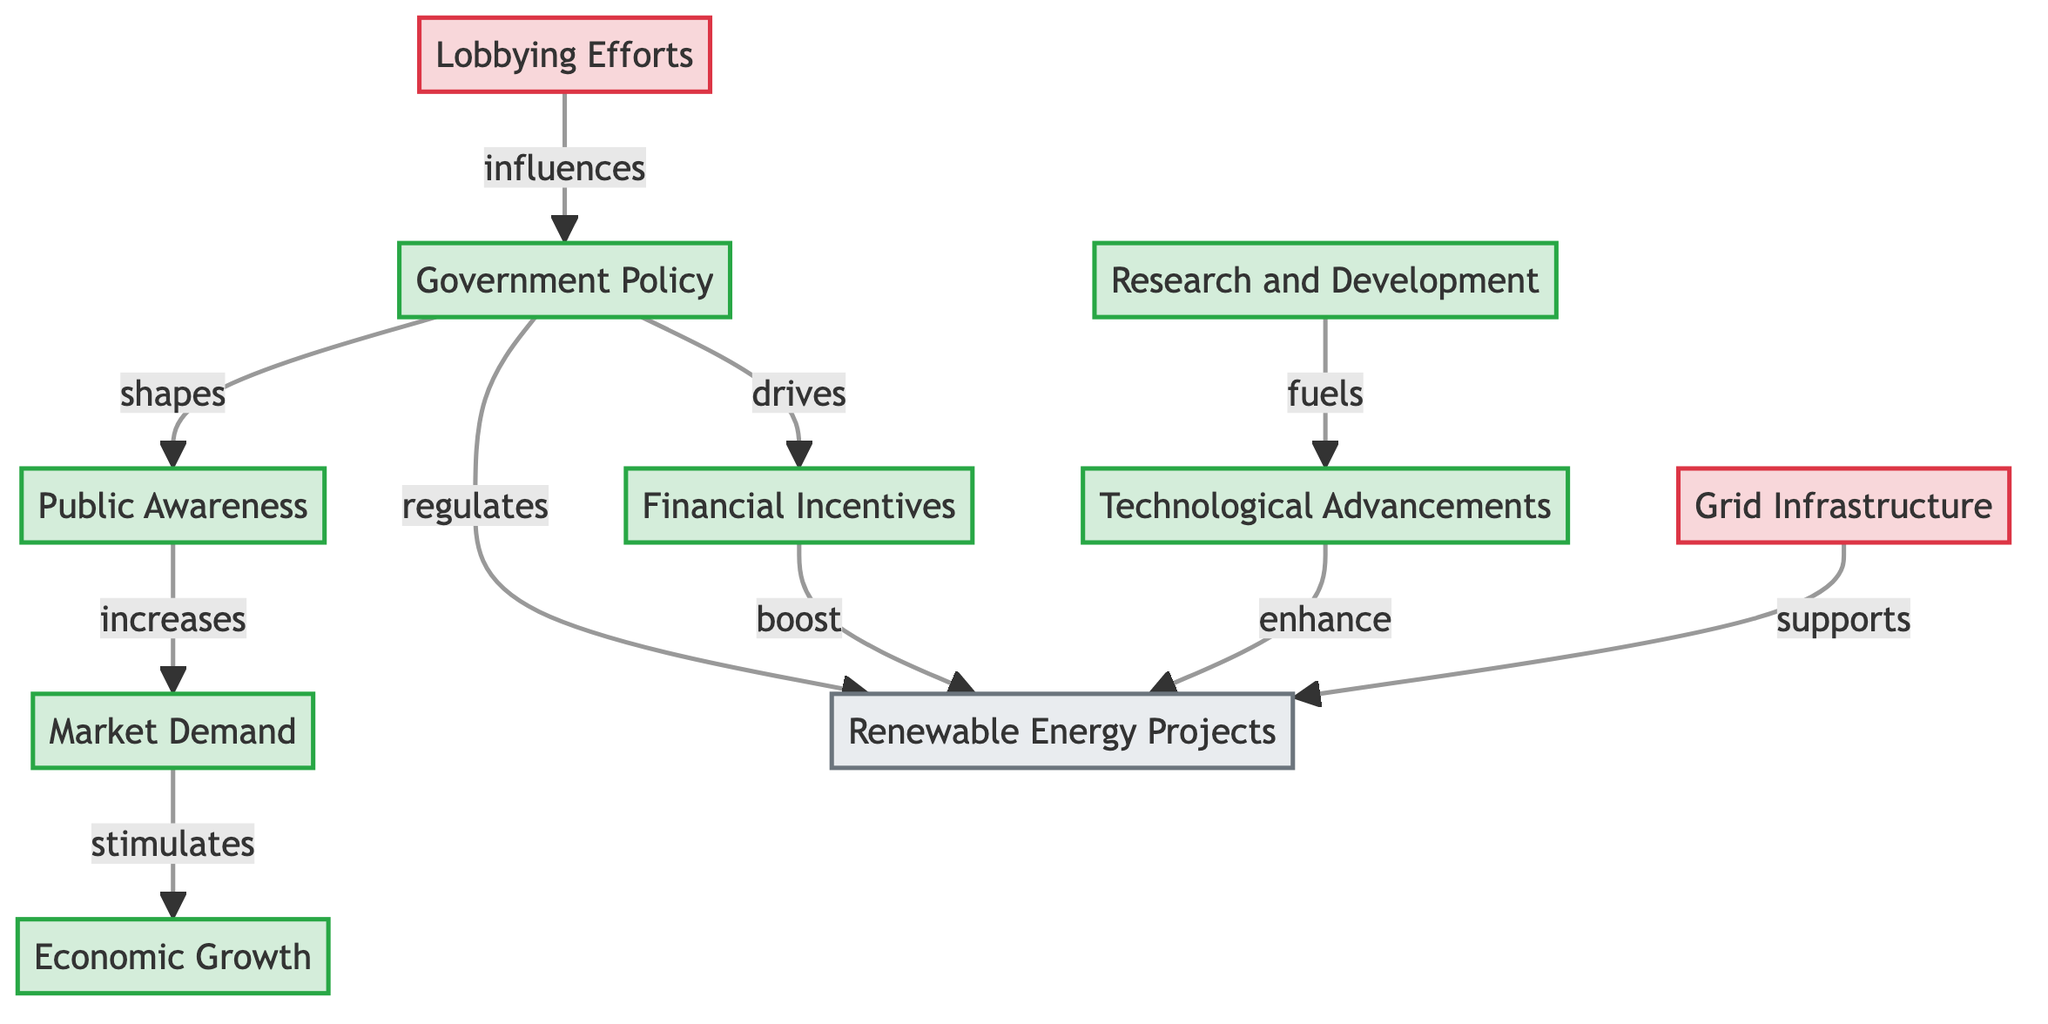What is the total number of nodes in the diagram? The diagram lists ten nodes related to renewable energy adoption incentives and barriers. Each node includes different elements such as Government Policy, Financial Incentives, Public Awareness, and others. By counting these distinct elements, we arrive at the total count of ten nodes.
Answer: 10 What does "Government Policy" drive? According to the diagram, the "Government Policy" directly drives the "Financial Incentives." This relationship is depicted by a single directed edge labeled "drives." Hence, by examining this specific connection, we identify the effect of government policy.
Answer: Financial Incentives How many barriers are present in the diagram? The diagram contains two nodes categorized as barriers: "Lobbying Efforts" and "Grid Infrastructure." By identifying and counting the nodes associated with this classification, we find the total number of barriers present.
Answer: 2 What node increases market demand? The diagram indicates that "Public Awareness" is the node that increases "Market Demand." This relationship is shown through a directed edge labeled "increases," connecting these two nodes. Thus, by following the relationship from the public awareness node, we identify the specific effect it has on market demand.
Answer: Public Awareness What enhances renewable energy projects? The diagram shows that "Technological Advancements" enhance "Renewable Energy Projects." This is represented by a directed edge labeled "enhance." By following the connection, it is clear what contributes positively to renewable energy projects.
Answer: Technological Advancements What is the relationship between market demand and economic growth? The diagram states that "Market Demand" stimulates "Economic Growth." This connection is indicated by a directed edge labeled "stimulates." Therefore, tracing the arrows reveals how one node positively impacts the other within the network.
Answer: stimulates What influences government policy according to the diagram? The diagram illustrates that "Lobbying Efforts" influences "Government Policy." This relationship is depicted through a directed edge labeled "influences." By following the arrow from lobbying efforts, we see how it interacts with government policy-making.
Answer: Lobbying Efforts Which node fuels technological advancements? The diagram identifies that "Research and Development" fuels "Technological Advancements." This connection is represented by a directed edge labeled "fuels." Hence, observing the linkage shows the contribution of research and development to technological progress.
Answer: Research and Development What supports renewable energy projects? The diagram indicates that "Grid Infrastructure" supports "Renewable Energy Projects." This relationship is shown with a directed edge labeled "supports." By examining the link, we confirm how grid infrastructure plays a role in fostering renewable energy projects.
Answer: Grid Infrastructure 